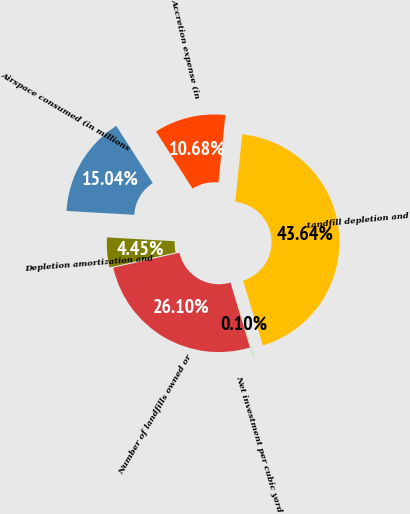Convert chart to OTSL. <chart><loc_0><loc_0><loc_500><loc_500><pie_chart><fcel>Number of landfills owned or<fcel>Net investment per cubic yard<fcel>Landfill depletion and<fcel>Accretion expense (in<fcel>Airspace consumed (in millions<fcel>Depletion amortization and<nl><fcel>26.1%<fcel>0.1%<fcel>43.64%<fcel>10.68%<fcel>15.04%<fcel>4.45%<nl></chart> 